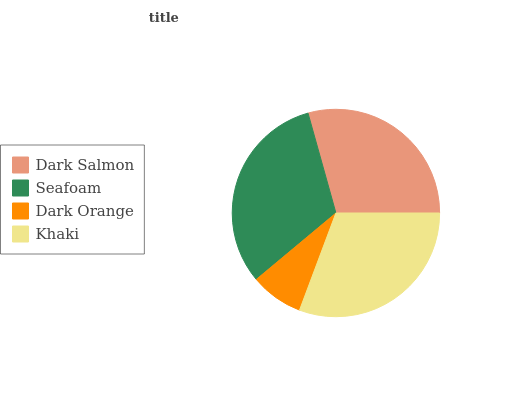Is Dark Orange the minimum?
Answer yes or no. Yes. Is Seafoam the maximum?
Answer yes or no. Yes. Is Seafoam the minimum?
Answer yes or no. No. Is Dark Orange the maximum?
Answer yes or no. No. Is Seafoam greater than Dark Orange?
Answer yes or no. Yes. Is Dark Orange less than Seafoam?
Answer yes or no. Yes. Is Dark Orange greater than Seafoam?
Answer yes or no. No. Is Seafoam less than Dark Orange?
Answer yes or no. No. Is Khaki the high median?
Answer yes or no. Yes. Is Dark Salmon the low median?
Answer yes or no. Yes. Is Dark Salmon the high median?
Answer yes or no. No. Is Khaki the low median?
Answer yes or no. No. 